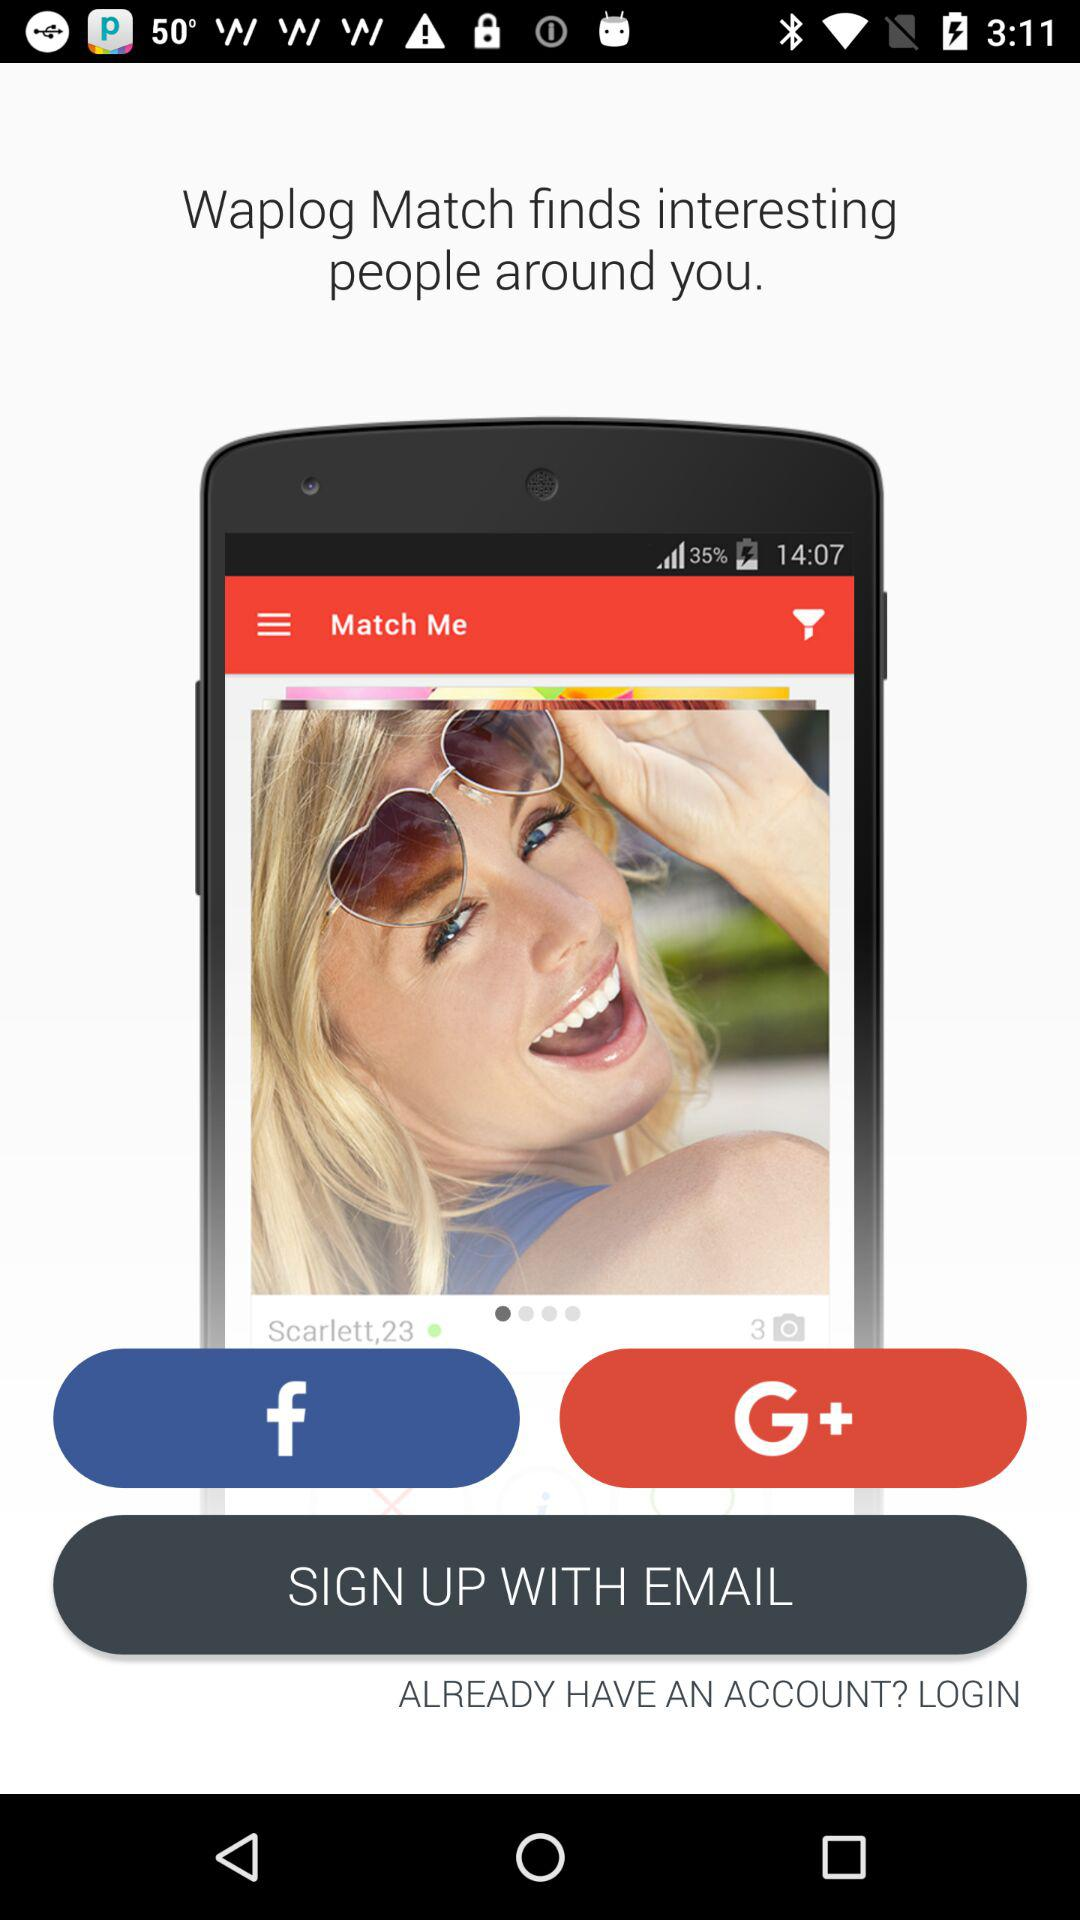What accounts can I use to sign up? The accounts are "Facebook", "Google+" and "EMAIL". 